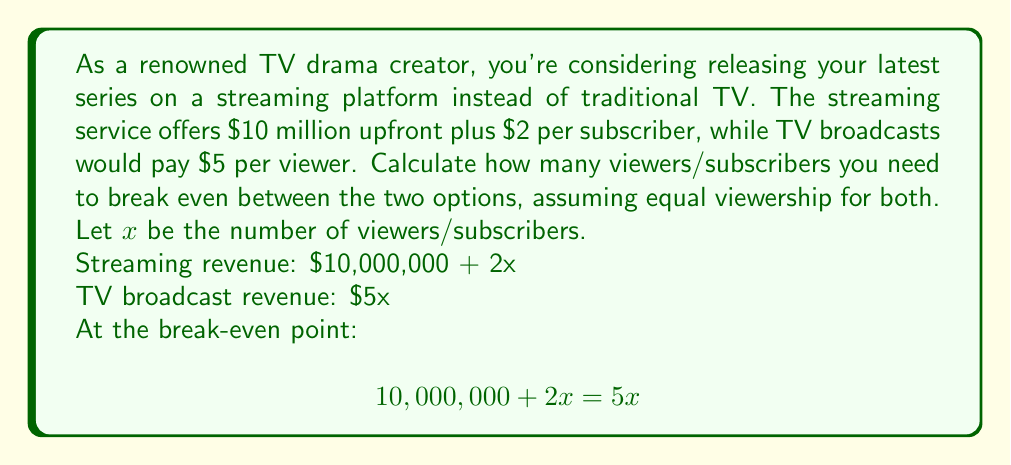Can you solve this math problem? To solve this system of equations, we'll follow these steps:

1) Set up the equation:
   $$10,000,000 + 2x = 5x$$

2) Subtract $2x$ from both sides:
   $$10,000,000 = 3x$$

3) Divide both sides by 3:
   $$\frac{10,000,000}{3} = x$$

4) Simplify:
   $$3,333,333.33 = x$$

5) Since we can't have a fractional viewer, we round up to the nearest whole number:
   $$x = 3,333,334$$

Therefore, you need 3,333,334 viewers/subscribers to break even between the streaming platform and traditional TV broadcast options.
Answer: 3,333,334 viewers/subscribers 